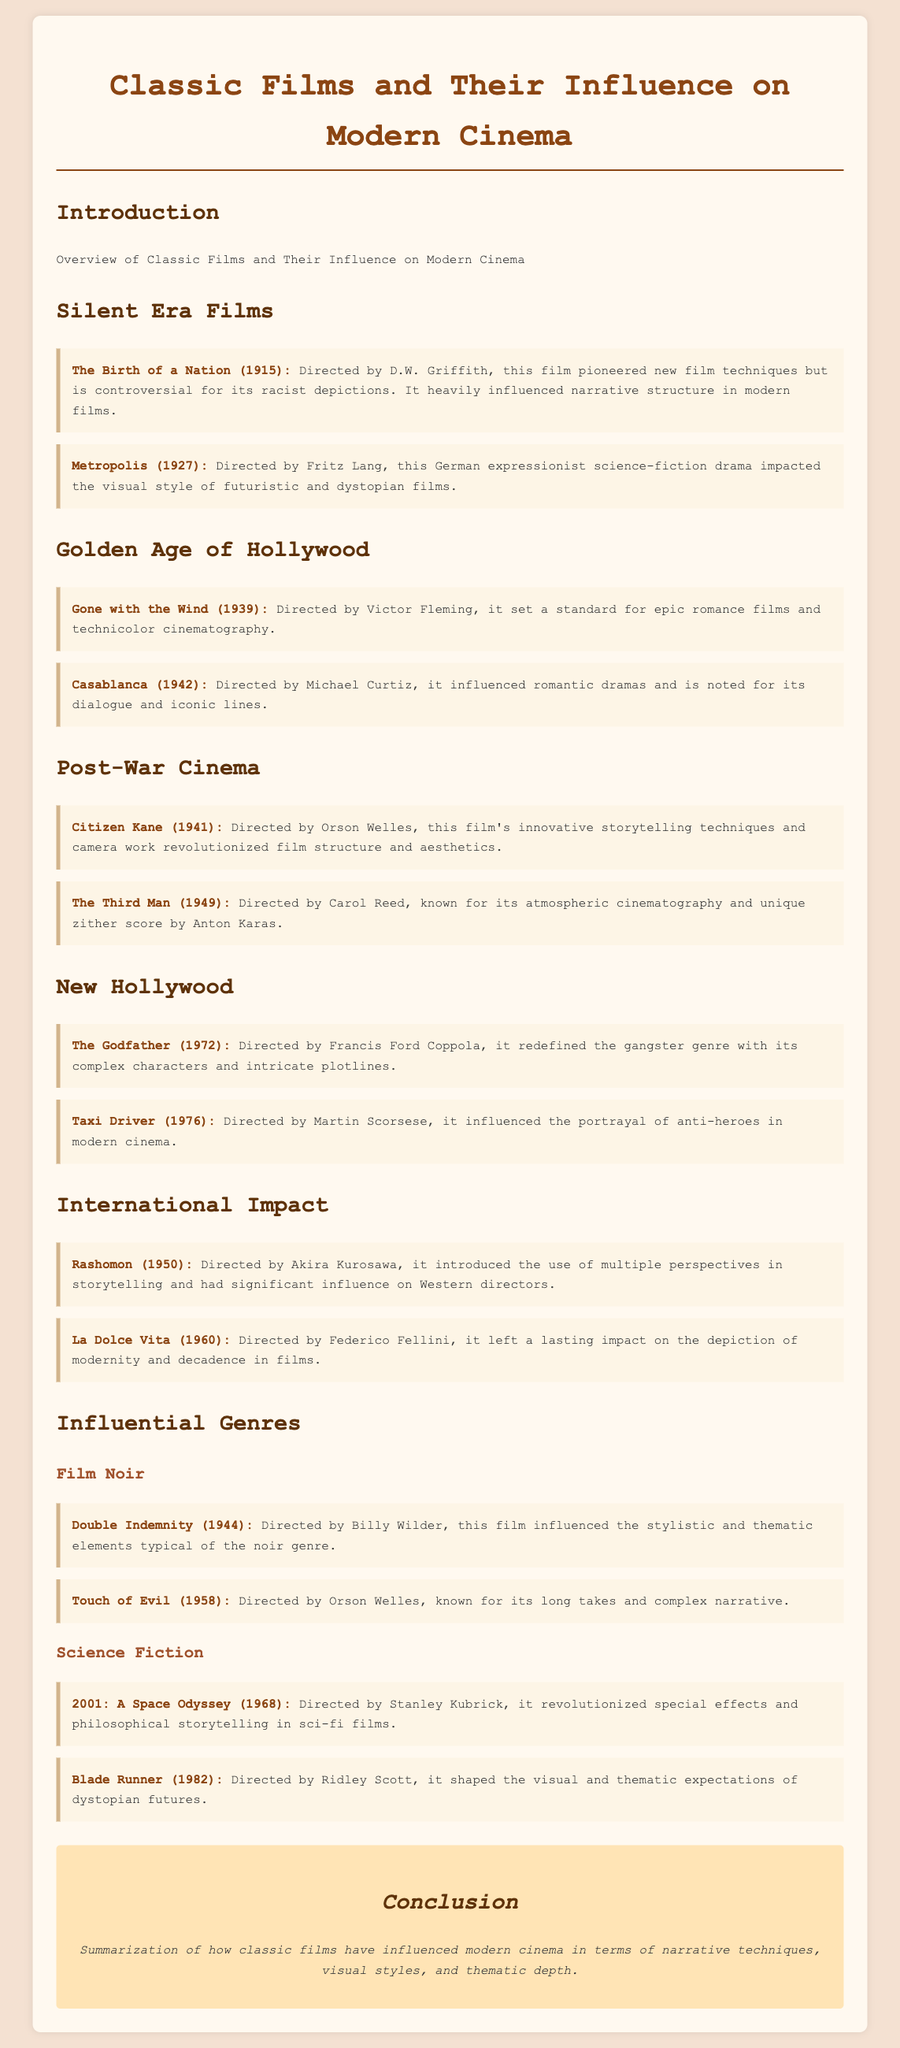what film directed by D.W. Griffith is mentioned? The film titled "The Birth of a Nation" is mentioned, which was directed by D.W. Griffith.
Answer: The Birth of a Nation which film set a standard for epic romance films? "Gone with the Wind" is described as setting a standard for epic romance films.
Answer: Gone with the Wind what year was "Citizen Kane" released? The document states that "Citizen Kane" was released in 1941.
Answer: 1941 who directed "La Dolce Vita"? The film "La Dolce Vita" was directed by Federico Fellini.
Answer: Federico Fellini which genre is associated with "Double Indemnity"? "Double Indemnity" is associated with the Film Noir genre.
Answer: Film Noir what aspect of "Metropolis" is highlighted? The document highlights its impact on the visual style of futuristic and dystopian films.
Answer: visual style how did "The Godfather" influence modern cinema? "The Godfather" redefined the gangster genre with its complex characters and intricate plotlines.
Answer: gangster genre which film introduced multiple perspectives in storytelling? The film "Rashomon" is noted for introducing the use of multiple perspectives.
Answer: Rashomon name a film that influenced the portrayal of anti-heroes. "Taxi Driver" is the film that influenced the portrayal of anti-heroes.
Answer: Taxi Driver 